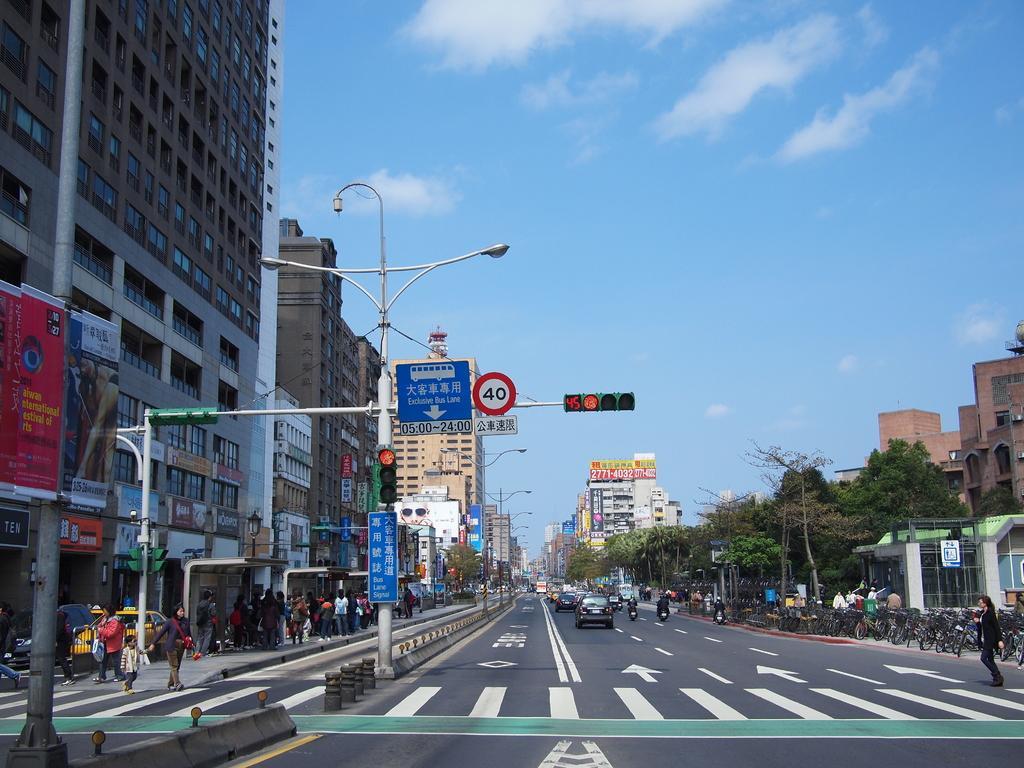Could you give a brief overview of what you see in this image? This is the picture of a city. In this image there are buildings, trees and there are vehicles on the road. There are group of people walking on the road. There are boards on the poles. At the top there is sky and there are clouds. At the bottom there is a road. 